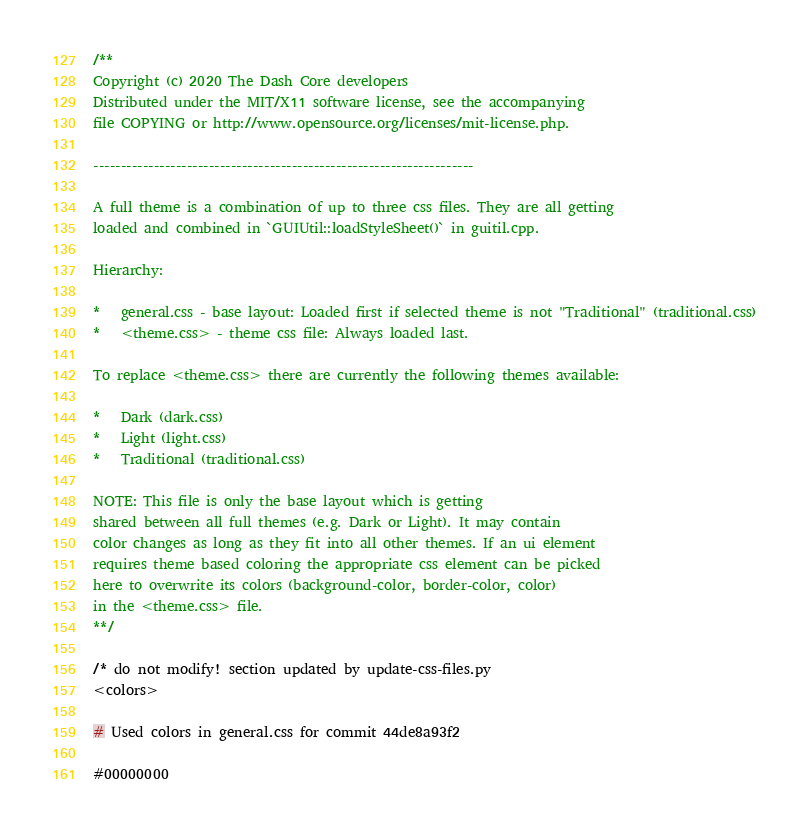Convert code to text. <code><loc_0><loc_0><loc_500><loc_500><_CSS_>/**
Copyright (c) 2020 The Dash Core developers
Distributed under the MIT/X11 software license, see the accompanying
file COPYING or http://www.opensource.org/licenses/mit-license.php.

---------------------------------------------------------------------

A full theme is a combination of up to three css files. They are all getting
loaded and combined in `GUIUtil::loadStyleSheet()` in guitil.cpp.

Hierarchy:

*   general.css - base layout: Loaded first if selected theme is not "Traditional" (traditional.css)
*   <theme.css> - theme css file: Always loaded last.

To replace <theme.css> there are currently the following themes available:

*   Dark (dark.css)
*   Light (light.css)
*   Traditional (traditional.css)

NOTE: This file is only the base layout which is getting
shared between all full themes (e.g. Dark or Light). It may contain
color changes as long as they fit into all other themes. If an ui element
requires theme based coloring the appropriate css element can be picked
here to overwrite its colors (background-color, border-color, color)
in the <theme.css> file.
**/

/* do not modify! section updated by update-css-files.py
<colors>

# Used colors in general.css for commit 44de8a93f2

#00000000</code> 